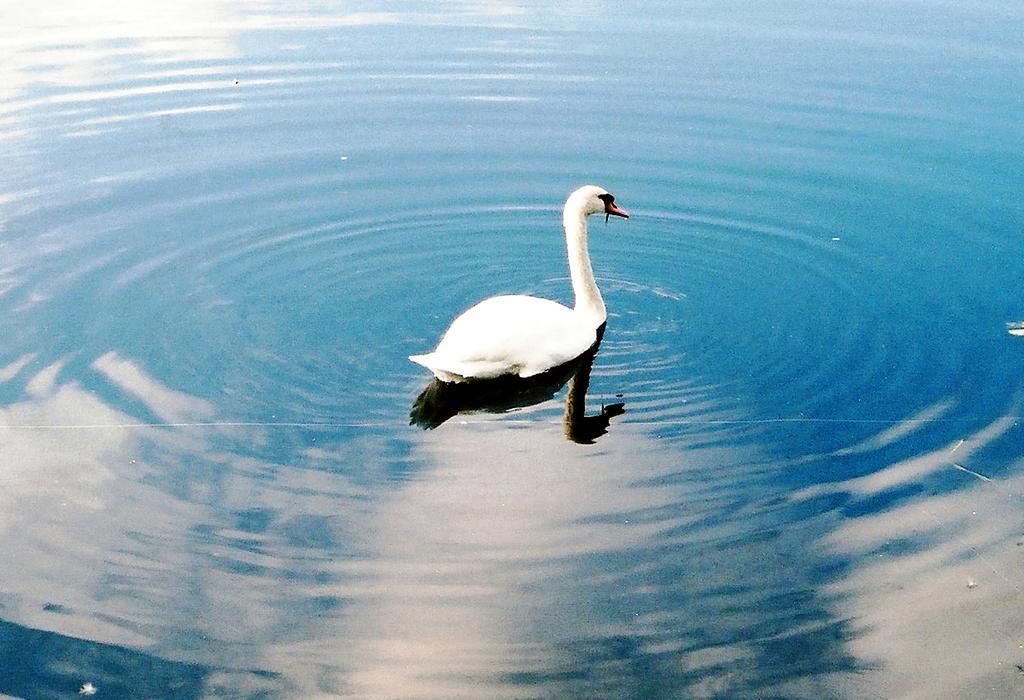How would you summarize this image in a sentence or two? In this image we can see a swan on the water. 